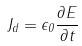<formula> <loc_0><loc_0><loc_500><loc_500>J _ { d } = \epsilon _ { 0 } \frac { \partial E } { \partial t }</formula> 